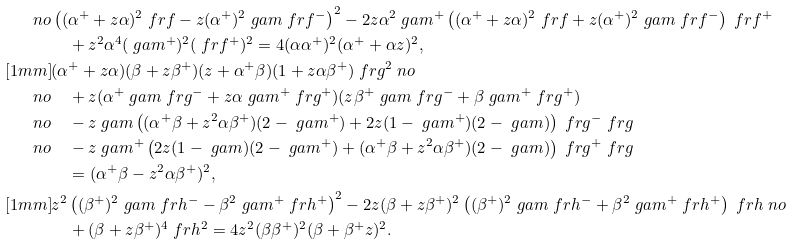<formula> <loc_0><loc_0><loc_500><loc_500>\ n o & \left ( ( \alpha ^ { + } + z \alpha ) ^ { 2 } \ f r f - z ( \alpha ^ { + } ) ^ { 2 } \ g a m \ f r f ^ { - } \right ) ^ { 2 } - 2 z \alpha ^ { 2 } \ g a m ^ { + } \left ( ( \alpha ^ { + } + z \alpha ) ^ { 2 } \ f r f + z ( \alpha ^ { + } ) ^ { 2 } \ g a m \ f r f ^ { - } \right ) \ f r f ^ { + } \\ & \quad + z ^ { 2 } \alpha ^ { 4 } ( \ g a m ^ { + } ) ^ { 2 } ( \ f r f ^ { + } ) ^ { 2 } = 4 ( \alpha \alpha ^ { + } ) ^ { 2 } ( \alpha ^ { + } + \alpha z ) ^ { 2 } , \\ [ 1 m m ] & ( \alpha ^ { + } + z \alpha ) ( \beta + z \beta ^ { + } ) ( z + \alpha ^ { + } \beta ) ( 1 + z \alpha \beta ^ { + } ) \ f r g ^ { 2 } \ n o \\ \ n o & \quad + z ( \alpha ^ { + } \ g a m \ f r g ^ { - } + z \alpha \ g a m ^ { + } \ f r g ^ { + } ) ( z \beta ^ { + } \ g a m \ f r g ^ { - } + \beta \ g a m ^ { + } \ f r g ^ { + } ) \\ \ n o & \quad - z \ g a m \left ( ( \alpha ^ { + } \beta + z ^ { 2 } \alpha \beta ^ { + } ) ( 2 - \ g a m ^ { + } ) + 2 z ( 1 - \ g a m ^ { + } ) ( 2 - \ g a m ) \right ) \ f r g ^ { - } \ f r g \\ \ n o & \quad - z \ g a m ^ { + } \left ( 2 z ( 1 - \ g a m ) ( 2 - \ g a m ^ { + } ) + ( \alpha ^ { + } \beta + z ^ { 2 } \alpha \beta ^ { + } ) ( 2 - \ g a m ) \right ) \ f r g ^ { + } \ f r g \\ & \quad = ( \alpha ^ { + } \beta - z ^ { 2 } \alpha \beta ^ { + } ) ^ { 2 } , \\ [ 1 m m ] & z ^ { 2 } \left ( ( \beta ^ { + } ) ^ { 2 } \ g a m \ f r h ^ { - } - \beta ^ { 2 } \ g a m ^ { + } \ f r h ^ { + } \right ) ^ { 2 } - 2 z ( \beta + z \beta ^ { + } ) ^ { 2 } \left ( ( \beta ^ { + } ) ^ { 2 } \ g a m \ f r h ^ { - } + \beta ^ { 2 } \ g a m ^ { + } \ f r h ^ { + } \right ) \ f r h \ n o \\ & \quad + ( \beta + z \beta ^ { + } ) ^ { 4 } \ f r h ^ { 2 } = 4 z ^ { 2 } ( \beta \beta ^ { + } ) ^ { 2 } ( \beta + \beta ^ { + } z ) ^ { 2 } .</formula> 